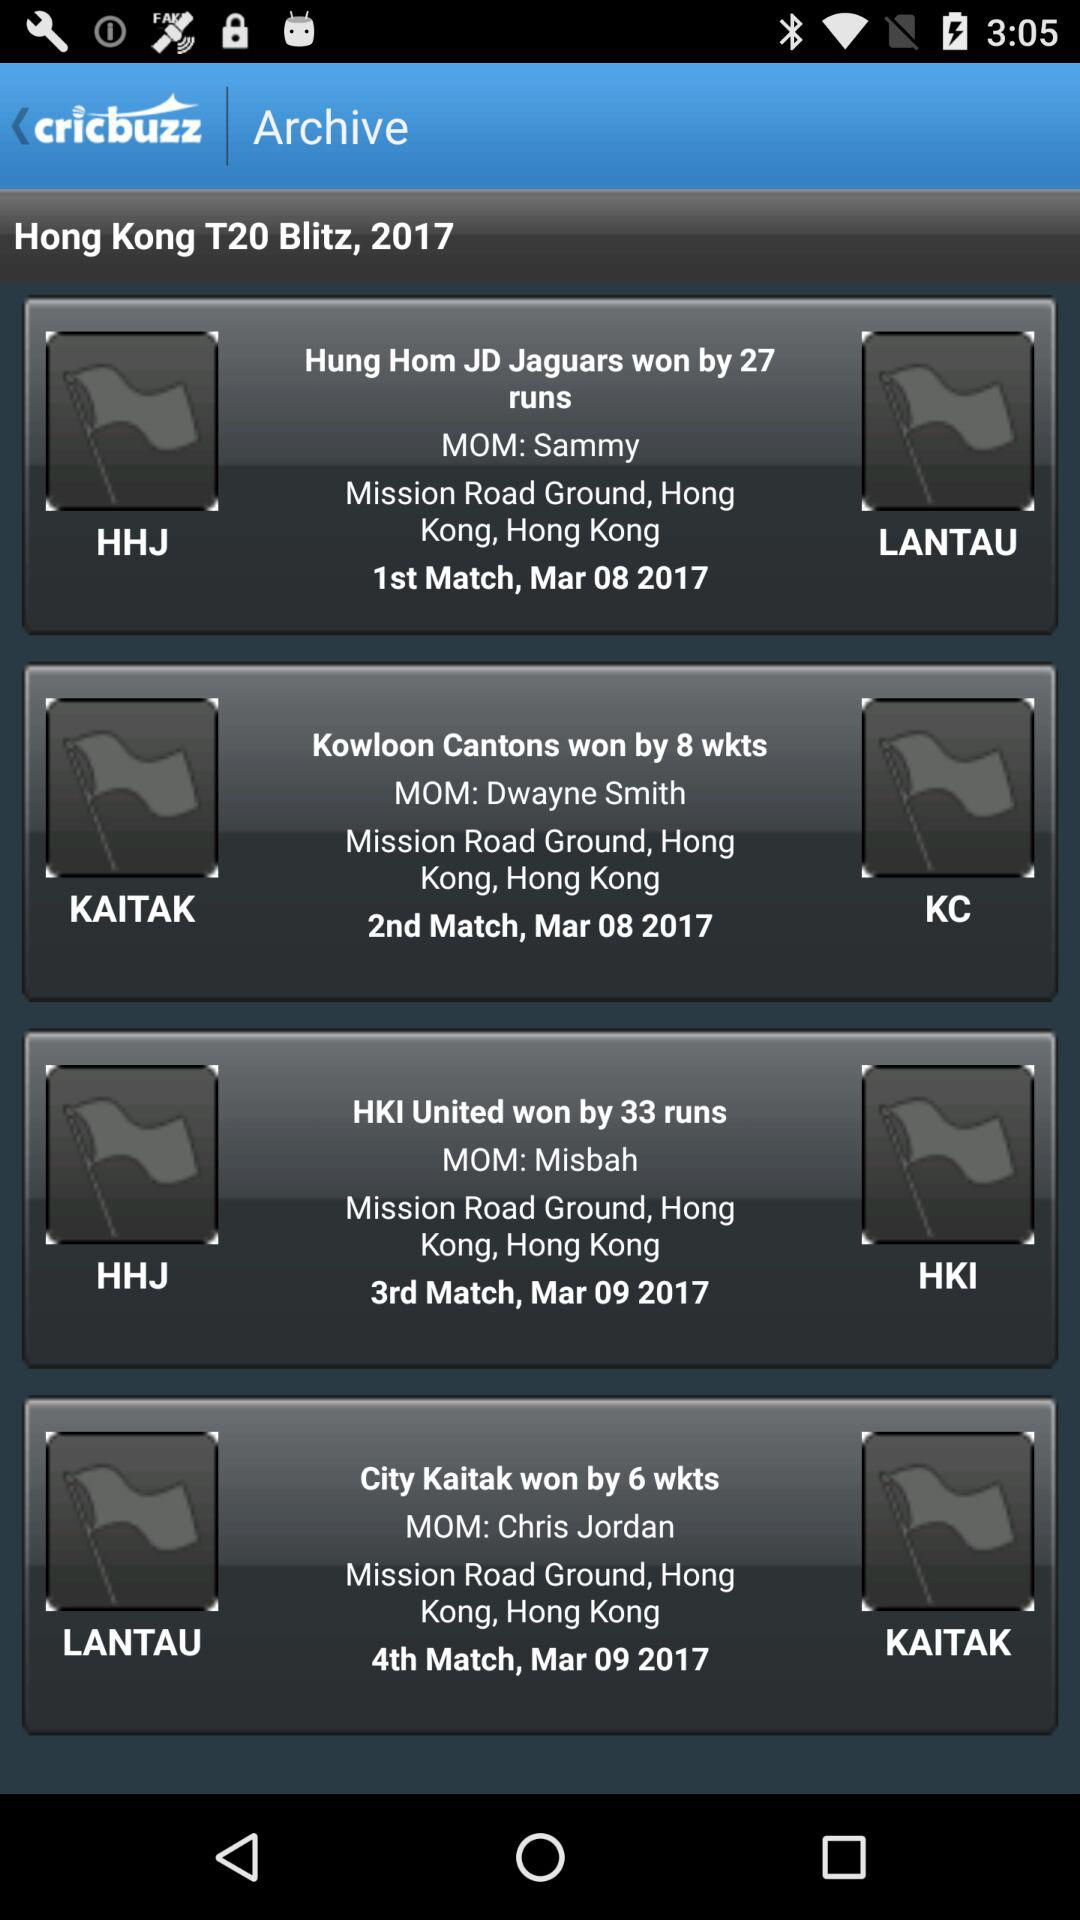What is the application name? The application name is "cricbuzz". 